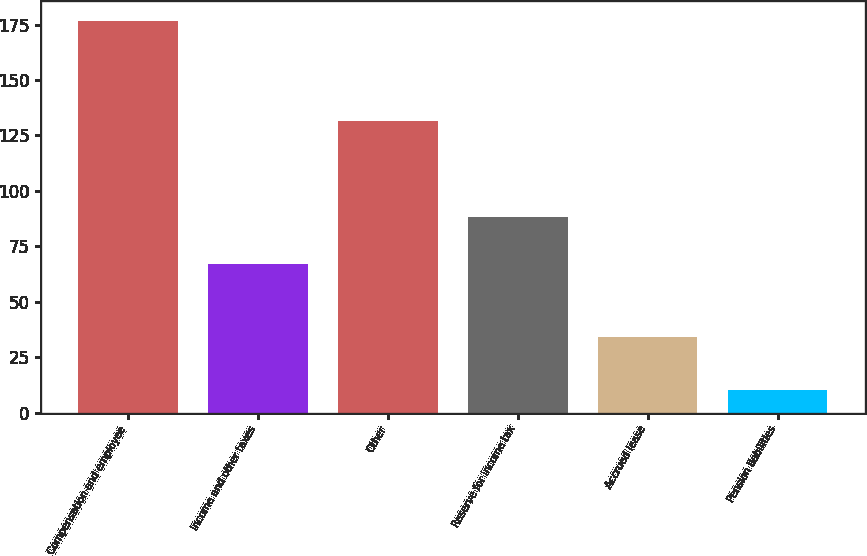Convert chart to OTSL. <chart><loc_0><loc_0><loc_500><loc_500><bar_chart><fcel>Compensation and employee<fcel>Income and other taxes<fcel>Other<fcel>Reserve for income tax<fcel>Accrued lease<fcel>Pension liabilities<nl><fcel>176.7<fcel>66.9<fcel>131.7<fcel>88.3<fcel>34.1<fcel>10<nl></chart> 